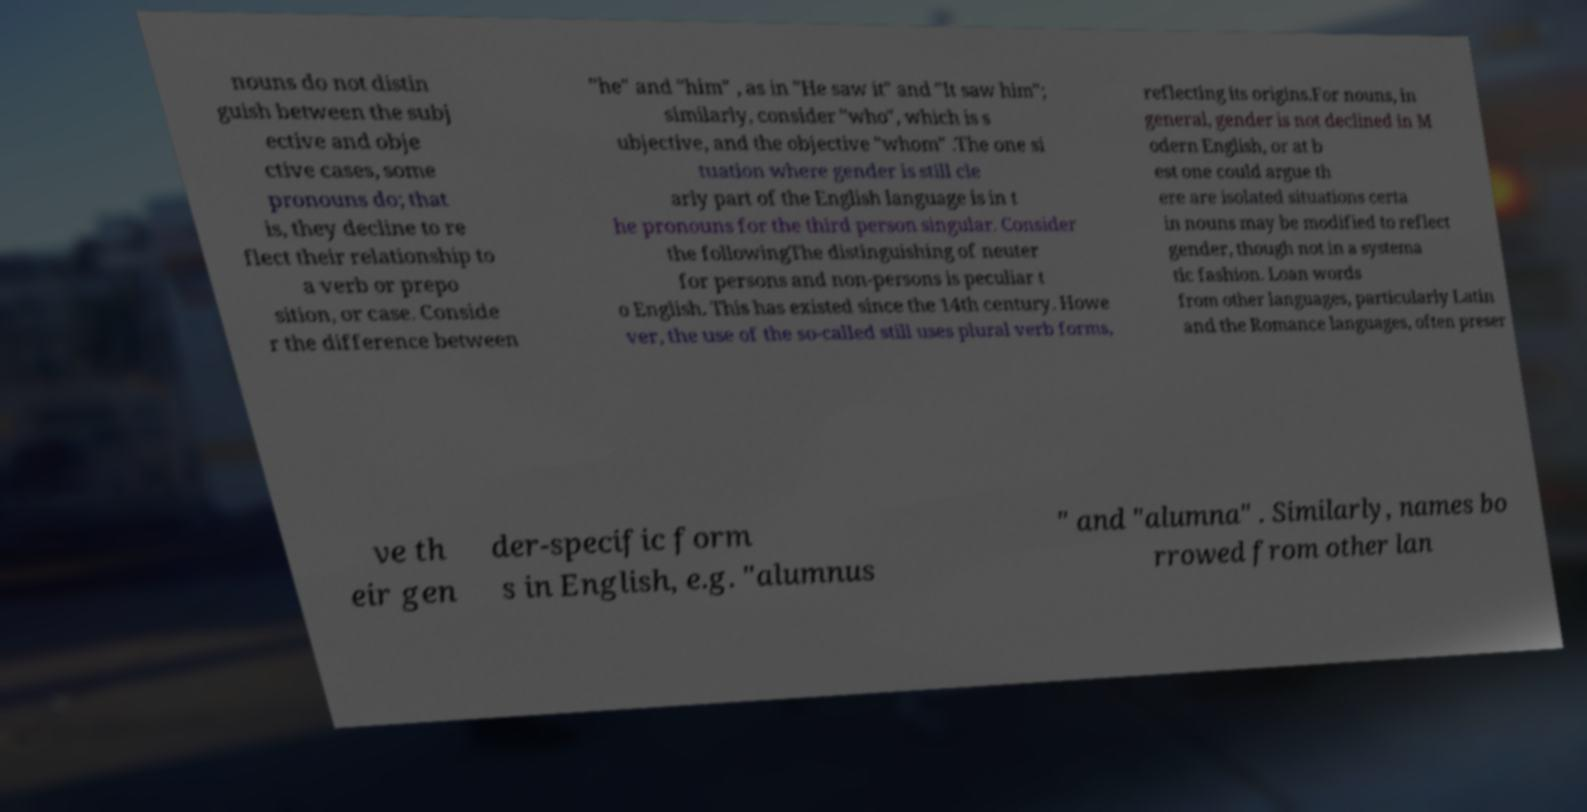There's text embedded in this image that I need extracted. Can you transcribe it verbatim? nouns do not distin guish between the subj ective and obje ctive cases, some pronouns do; that is, they decline to re flect their relationship to a verb or prepo sition, or case. Conside r the difference between "he" and "him" , as in "He saw it" and "It saw him"; similarly, consider "who", which is s ubjective, and the objective "whom" .The one si tuation where gender is still cle arly part of the English language is in t he pronouns for the third person singular. Consider the followingThe distinguishing of neuter for persons and non-persons is peculiar t o English. This has existed since the 14th century. Howe ver, the use of the so-called still uses plural verb forms, reflecting its origins.For nouns, in general, gender is not declined in M odern English, or at b est one could argue th ere are isolated situations certa in nouns may be modified to reflect gender, though not in a systema tic fashion. Loan words from other languages, particularly Latin and the Romance languages, often preser ve th eir gen der-specific form s in English, e.g. "alumnus " and "alumna" . Similarly, names bo rrowed from other lan 